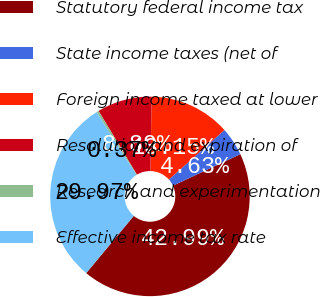Convert chart. <chart><loc_0><loc_0><loc_500><loc_500><pie_chart><fcel>Statutory federal income tax<fcel>State income taxes (net of<fcel>Foreign income taxed at lower<fcel>Resolution and expiration of<fcel>Research and experimentation<fcel>Effective income tax rate<nl><fcel>42.99%<fcel>4.63%<fcel>13.15%<fcel>8.89%<fcel>0.37%<fcel>29.97%<nl></chart> 